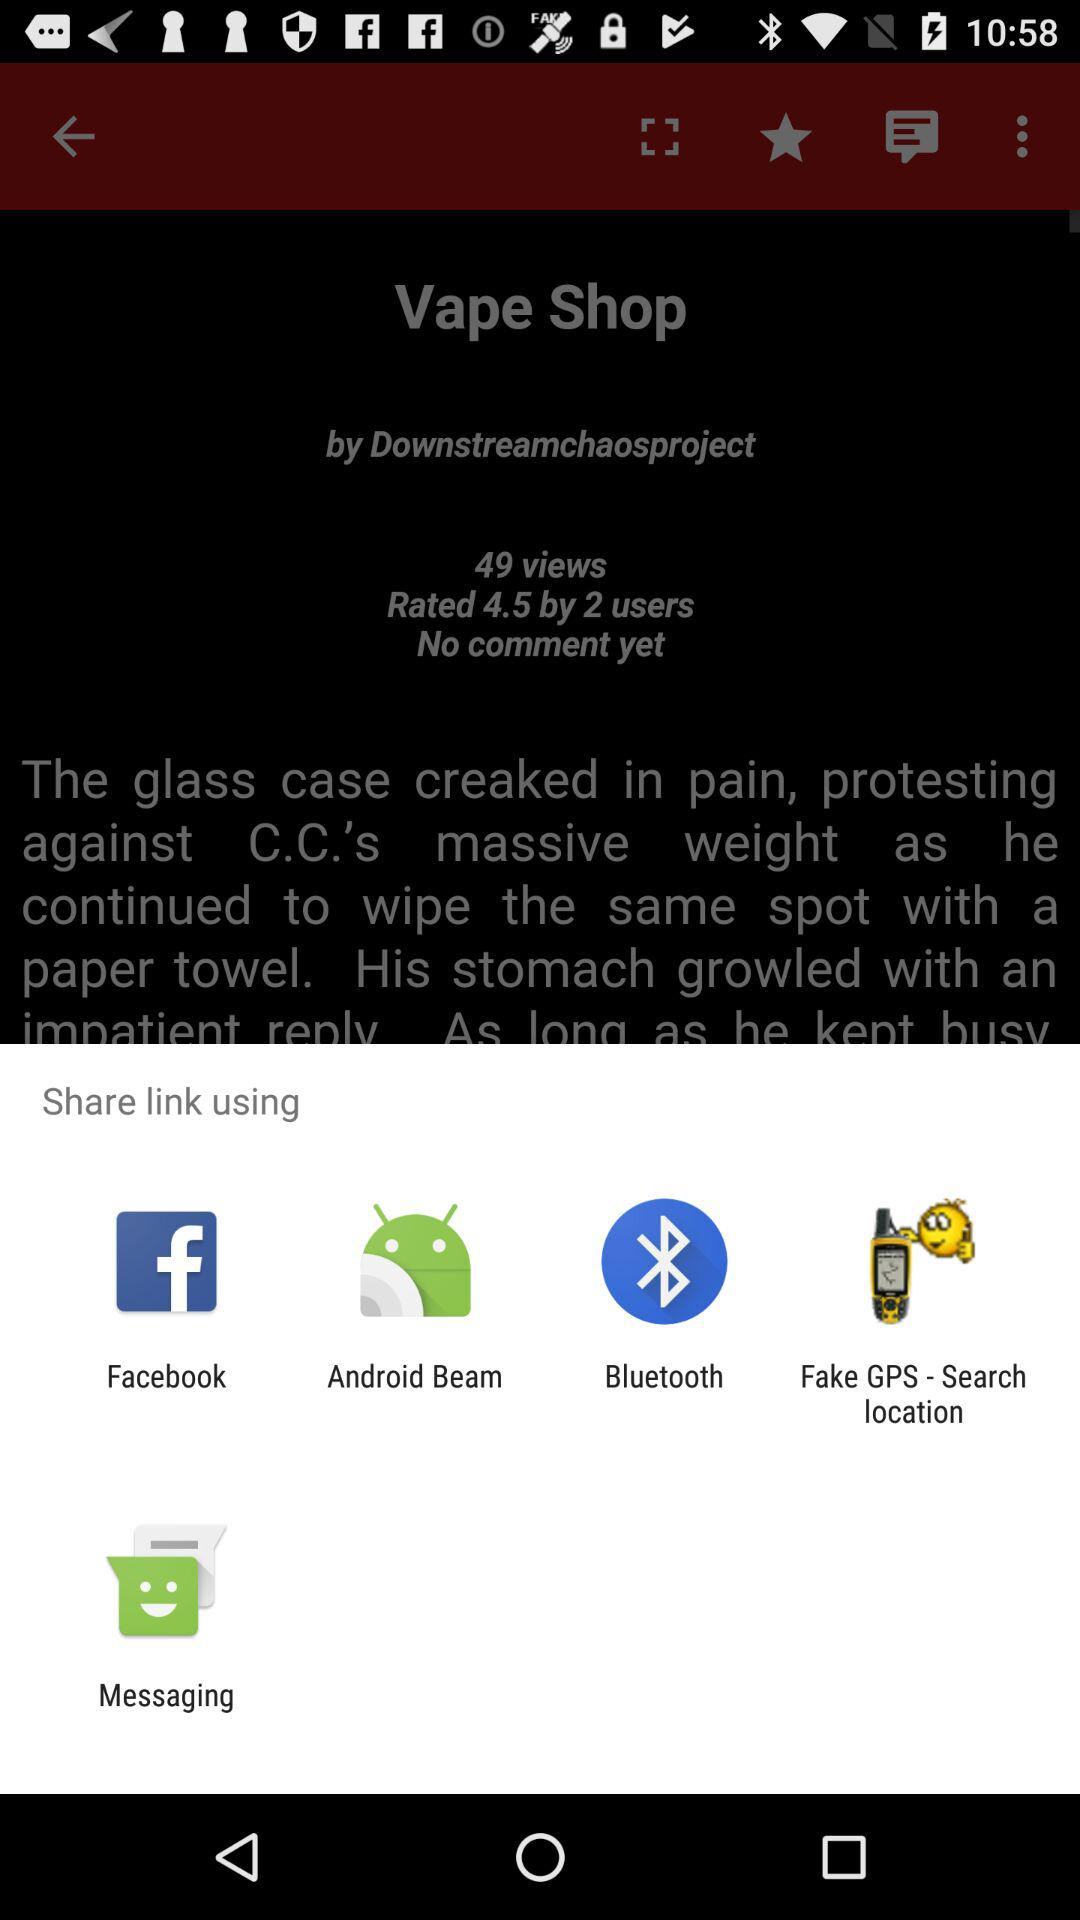How many share links are there?
Answer the question using a single word or phrase. 5 